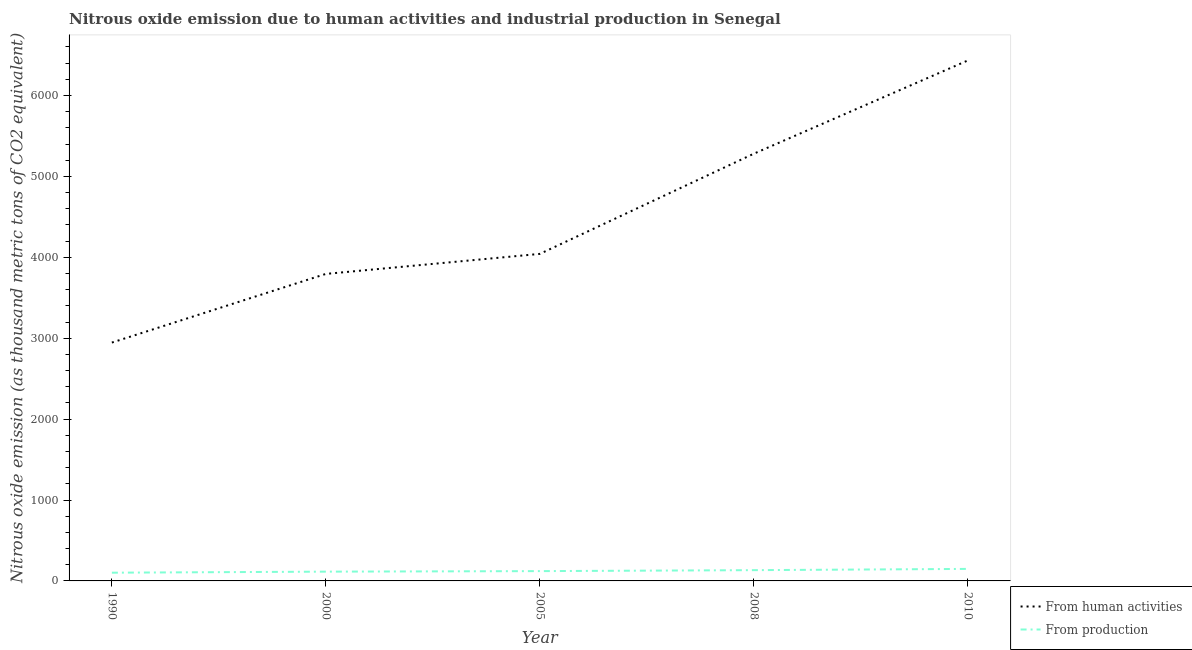How many different coloured lines are there?
Your answer should be compact. 2. What is the amount of emissions generated from industries in 2005?
Offer a terse response. 121.2. Across all years, what is the maximum amount of emissions from human activities?
Make the answer very short. 6433. Across all years, what is the minimum amount of emissions generated from industries?
Provide a succinct answer. 101.7. What is the total amount of emissions from human activities in the graph?
Provide a short and direct response. 2.25e+04. What is the difference between the amount of emissions generated from industries in 2005 and that in 2008?
Your answer should be very brief. -11.9. What is the difference between the amount of emissions generated from industries in 2005 and the amount of emissions from human activities in 2000?
Your answer should be compact. -3673.7. What is the average amount of emissions generated from industries per year?
Your response must be concise. 123.86. In the year 2000, what is the difference between the amount of emissions from human activities and amount of emissions generated from industries?
Keep it short and to the point. 3680.2. What is the ratio of the amount of emissions generated from industries in 1990 to that in 2008?
Provide a succinct answer. 0.76. Is the amount of emissions generated from industries in 1990 less than that in 2005?
Your answer should be compact. Yes. Is the difference between the amount of emissions generated from industries in 1990 and 2010 greater than the difference between the amount of emissions from human activities in 1990 and 2010?
Ensure brevity in your answer.  Yes. What is the difference between the highest and the second highest amount of emissions from human activities?
Make the answer very short. 1152.3. What is the difference between the highest and the lowest amount of emissions from human activities?
Your response must be concise. 3486.7. Is the sum of the amount of emissions generated from industries in 1990 and 2005 greater than the maximum amount of emissions from human activities across all years?
Make the answer very short. No. Does the amount of emissions from human activities monotonically increase over the years?
Keep it short and to the point. Yes. How many lines are there?
Offer a terse response. 2. What is the difference between two consecutive major ticks on the Y-axis?
Offer a very short reply. 1000. Does the graph contain grids?
Offer a very short reply. No. How many legend labels are there?
Your response must be concise. 2. What is the title of the graph?
Give a very brief answer. Nitrous oxide emission due to human activities and industrial production in Senegal. Does "Long-term debt" appear as one of the legend labels in the graph?
Your answer should be compact. No. What is the label or title of the Y-axis?
Offer a terse response. Nitrous oxide emission (as thousand metric tons of CO2 equivalent). What is the Nitrous oxide emission (as thousand metric tons of CO2 equivalent) in From human activities in 1990?
Your answer should be very brief. 2946.3. What is the Nitrous oxide emission (as thousand metric tons of CO2 equivalent) of From production in 1990?
Your answer should be very brief. 101.7. What is the Nitrous oxide emission (as thousand metric tons of CO2 equivalent) of From human activities in 2000?
Give a very brief answer. 3794.9. What is the Nitrous oxide emission (as thousand metric tons of CO2 equivalent) in From production in 2000?
Provide a succinct answer. 114.7. What is the Nitrous oxide emission (as thousand metric tons of CO2 equivalent) of From human activities in 2005?
Provide a short and direct response. 4042.4. What is the Nitrous oxide emission (as thousand metric tons of CO2 equivalent) in From production in 2005?
Your response must be concise. 121.2. What is the Nitrous oxide emission (as thousand metric tons of CO2 equivalent) in From human activities in 2008?
Provide a succinct answer. 5280.7. What is the Nitrous oxide emission (as thousand metric tons of CO2 equivalent) in From production in 2008?
Ensure brevity in your answer.  133.1. What is the Nitrous oxide emission (as thousand metric tons of CO2 equivalent) in From human activities in 2010?
Give a very brief answer. 6433. What is the Nitrous oxide emission (as thousand metric tons of CO2 equivalent) in From production in 2010?
Offer a terse response. 148.6. Across all years, what is the maximum Nitrous oxide emission (as thousand metric tons of CO2 equivalent) of From human activities?
Your response must be concise. 6433. Across all years, what is the maximum Nitrous oxide emission (as thousand metric tons of CO2 equivalent) of From production?
Make the answer very short. 148.6. Across all years, what is the minimum Nitrous oxide emission (as thousand metric tons of CO2 equivalent) of From human activities?
Provide a short and direct response. 2946.3. Across all years, what is the minimum Nitrous oxide emission (as thousand metric tons of CO2 equivalent) of From production?
Provide a short and direct response. 101.7. What is the total Nitrous oxide emission (as thousand metric tons of CO2 equivalent) of From human activities in the graph?
Your answer should be compact. 2.25e+04. What is the total Nitrous oxide emission (as thousand metric tons of CO2 equivalent) in From production in the graph?
Your answer should be very brief. 619.3. What is the difference between the Nitrous oxide emission (as thousand metric tons of CO2 equivalent) of From human activities in 1990 and that in 2000?
Provide a succinct answer. -848.6. What is the difference between the Nitrous oxide emission (as thousand metric tons of CO2 equivalent) in From human activities in 1990 and that in 2005?
Your answer should be very brief. -1096.1. What is the difference between the Nitrous oxide emission (as thousand metric tons of CO2 equivalent) in From production in 1990 and that in 2005?
Your answer should be compact. -19.5. What is the difference between the Nitrous oxide emission (as thousand metric tons of CO2 equivalent) in From human activities in 1990 and that in 2008?
Offer a terse response. -2334.4. What is the difference between the Nitrous oxide emission (as thousand metric tons of CO2 equivalent) of From production in 1990 and that in 2008?
Give a very brief answer. -31.4. What is the difference between the Nitrous oxide emission (as thousand metric tons of CO2 equivalent) of From human activities in 1990 and that in 2010?
Offer a very short reply. -3486.7. What is the difference between the Nitrous oxide emission (as thousand metric tons of CO2 equivalent) of From production in 1990 and that in 2010?
Offer a terse response. -46.9. What is the difference between the Nitrous oxide emission (as thousand metric tons of CO2 equivalent) of From human activities in 2000 and that in 2005?
Provide a succinct answer. -247.5. What is the difference between the Nitrous oxide emission (as thousand metric tons of CO2 equivalent) of From production in 2000 and that in 2005?
Offer a very short reply. -6.5. What is the difference between the Nitrous oxide emission (as thousand metric tons of CO2 equivalent) in From human activities in 2000 and that in 2008?
Offer a terse response. -1485.8. What is the difference between the Nitrous oxide emission (as thousand metric tons of CO2 equivalent) of From production in 2000 and that in 2008?
Your answer should be compact. -18.4. What is the difference between the Nitrous oxide emission (as thousand metric tons of CO2 equivalent) of From human activities in 2000 and that in 2010?
Offer a very short reply. -2638.1. What is the difference between the Nitrous oxide emission (as thousand metric tons of CO2 equivalent) of From production in 2000 and that in 2010?
Give a very brief answer. -33.9. What is the difference between the Nitrous oxide emission (as thousand metric tons of CO2 equivalent) in From human activities in 2005 and that in 2008?
Make the answer very short. -1238.3. What is the difference between the Nitrous oxide emission (as thousand metric tons of CO2 equivalent) in From production in 2005 and that in 2008?
Provide a short and direct response. -11.9. What is the difference between the Nitrous oxide emission (as thousand metric tons of CO2 equivalent) in From human activities in 2005 and that in 2010?
Make the answer very short. -2390.6. What is the difference between the Nitrous oxide emission (as thousand metric tons of CO2 equivalent) of From production in 2005 and that in 2010?
Your answer should be very brief. -27.4. What is the difference between the Nitrous oxide emission (as thousand metric tons of CO2 equivalent) in From human activities in 2008 and that in 2010?
Give a very brief answer. -1152.3. What is the difference between the Nitrous oxide emission (as thousand metric tons of CO2 equivalent) in From production in 2008 and that in 2010?
Offer a very short reply. -15.5. What is the difference between the Nitrous oxide emission (as thousand metric tons of CO2 equivalent) in From human activities in 1990 and the Nitrous oxide emission (as thousand metric tons of CO2 equivalent) in From production in 2000?
Provide a succinct answer. 2831.6. What is the difference between the Nitrous oxide emission (as thousand metric tons of CO2 equivalent) in From human activities in 1990 and the Nitrous oxide emission (as thousand metric tons of CO2 equivalent) in From production in 2005?
Provide a succinct answer. 2825.1. What is the difference between the Nitrous oxide emission (as thousand metric tons of CO2 equivalent) in From human activities in 1990 and the Nitrous oxide emission (as thousand metric tons of CO2 equivalent) in From production in 2008?
Offer a very short reply. 2813.2. What is the difference between the Nitrous oxide emission (as thousand metric tons of CO2 equivalent) in From human activities in 1990 and the Nitrous oxide emission (as thousand metric tons of CO2 equivalent) in From production in 2010?
Your answer should be very brief. 2797.7. What is the difference between the Nitrous oxide emission (as thousand metric tons of CO2 equivalent) in From human activities in 2000 and the Nitrous oxide emission (as thousand metric tons of CO2 equivalent) in From production in 2005?
Your answer should be compact. 3673.7. What is the difference between the Nitrous oxide emission (as thousand metric tons of CO2 equivalent) in From human activities in 2000 and the Nitrous oxide emission (as thousand metric tons of CO2 equivalent) in From production in 2008?
Your answer should be very brief. 3661.8. What is the difference between the Nitrous oxide emission (as thousand metric tons of CO2 equivalent) of From human activities in 2000 and the Nitrous oxide emission (as thousand metric tons of CO2 equivalent) of From production in 2010?
Keep it short and to the point. 3646.3. What is the difference between the Nitrous oxide emission (as thousand metric tons of CO2 equivalent) of From human activities in 2005 and the Nitrous oxide emission (as thousand metric tons of CO2 equivalent) of From production in 2008?
Your response must be concise. 3909.3. What is the difference between the Nitrous oxide emission (as thousand metric tons of CO2 equivalent) of From human activities in 2005 and the Nitrous oxide emission (as thousand metric tons of CO2 equivalent) of From production in 2010?
Provide a succinct answer. 3893.8. What is the difference between the Nitrous oxide emission (as thousand metric tons of CO2 equivalent) in From human activities in 2008 and the Nitrous oxide emission (as thousand metric tons of CO2 equivalent) in From production in 2010?
Your response must be concise. 5132.1. What is the average Nitrous oxide emission (as thousand metric tons of CO2 equivalent) of From human activities per year?
Provide a succinct answer. 4499.46. What is the average Nitrous oxide emission (as thousand metric tons of CO2 equivalent) in From production per year?
Keep it short and to the point. 123.86. In the year 1990, what is the difference between the Nitrous oxide emission (as thousand metric tons of CO2 equivalent) in From human activities and Nitrous oxide emission (as thousand metric tons of CO2 equivalent) in From production?
Give a very brief answer. 2844.6. In the year 2000, what is the difference between the Nitrous oxide emission (as thousand metric tons of CO2 equivalent) in From human activities and Nitrous oxide emission (as thousand metric tons of CO2 equivalent) in From production?
Your answer should be very brief. 3680.2. In the year 2005, what is the difference between the Nitrous oxide emission (as thousand metric tons of CO2 equivalent) in From human activities and Nitrous oxide emission (as thousand metric tons of CO2 equivalent) in From production?
Your answer should be compact. 3921.2. In the year 2008, what is the difference between the Nitrous oxide emission (as thousand metric tons of CO2 equivalent) of From human activities and Nitrous oxide emission (as thousand metric tons of CO2 equivalent) of From production?
Ensure brevity in your answer.  5147.6. In the year 2010, what is the difference between the Nitrous oxide emission (as thousand metric tons of CO2 equivalent) in From human activities and Nitrous oxide emission (as thousand metric tons of CO2 equivalent) in From production?
Your answer should be compact. 6284.4. What is the ratio of the Nitrous oxide emission (as thousand metric tons of CO2 equivalent) of From human activities in 1990 to that in 2000?
Your answer should be compact. 0.78. What is the ratio of the Nitrous oxide emission (as thousand metric tons of CO2 equivalent) of From production in 1990 to that in 2000?
Provide a short and direct response. 0.89. What is the ratio of the Nitrous oxide emission (as thousand metric tons of CO2 equivalent) in From human activities in 1990 to that in 2005?
Provide a short and direct response. 0.73. What is the ratio of the Nitrous oxide emission (as thousand metric tons of CO2 equivalent) of From production in 1990 to that in 2005?
Give a very brief answer. 0.84. What is the ratio of the Nitrous oxide emission (as thousand metric tons of CO2 equivalent) of From human activities in 1990 to that in 2008?
Keep it short and to the point. 0.56. What is the ratio of the Nitrous oxide emission (as thousand metric tons of CO2 equivalent) in From production in 1990 to that in 2008?
Offer a terse response. 0.76. What is the ratio of the Nitrous oxide emission (as thousand metric tons of CO2 equivalent) in From human activities in 1990 to that in 2010?
Your answer should be very brief. 0.46. What is the ratio of the Nitrous oxide emission (as thousand metric tons of CO2 equivalent) in From production in 1990 to that in 2010?
Make the answer very short. 0.68. What is the ratio of the Nitrous oxide emission (as thousand metric tons of CO2 equivalent) in From human activities in 2000 to that in 2005?
Offer a very short reply. 0.94. What is the ratio of the Nitrous oxide emission (as thousand metric tons of CO2 equivalent) in From production in 2000 to that in 2005?
Offer a very short reply. 0.95. What is the ratio of the Nitrous oxide emission (as thousand metric tons of CO2 equivalent) of From human activities in 2000 to that in 2008?
Provide a short and direct response. 0.72. What is the ratio of the Nitrous oxide emission (as thousand metric tons of CO2 equivalent) of From production in 2000 to that in 2008?
Your answer should be compact. 0.86. What is the ratio of the Nitrous oxide emission (as thousand metric tons of CO2 equivalent) in From human activities in 2000 to that in 2010?
Keep it short and to the point. 0.59. What is the ratio of the Nitrous oxide emission (as thousand metric tons of CO2 equivalent) of From production in 2000 to that in 2010?
Provide a succinct answer. 0.77. What is the ratio of the Nitrous oxide emission (as thousand metric tons of CO2 equivalent) of From human activities in 2005 to that in 2008?
Give a very brief answer. 0.77. What is the ratio of the Nitrous oxide emission (as thousand metric tons of CO2 equivalent) in From production in 2005 to that in 2008?
Offer a very short reply. 0.91. What is the ratio of the Nitrous oxide emission (as thousand metric tons of CO2 equivalent) in From human activities in 2005 to that in 2010?
Offer a terse response. 0.63. What is the ratio of the Nitrous oxide emission (as thousand metric tons of CO2 equivalent) of From production in 2005 to that in 2010?
Offer a terse response. 0.82. What is the ratio of the Nitrous oxide emission (as thousand metric tons of CO2 equivalent) of From human activities in 2008 to that in 2010?
Give a very brief answer. 0.82. What is the ratio of the Nitrous oxide emission (as thousand metric tons of CO2 equivalent) of From production in 2008 to that in 2010?
Offer a terse response. 0.9. What is the difference between the highest and the second highest Nitrous oxide emission (as thousand metric tons of CO2 equivalent) of From human activities?
Provide a short and direct response. 1152.3. What is the difference between the highest and the lowest Nitrous oxide emission (as thousand metric tons of CO2 equivalent) of From human activities?
Provide a short and direct response. 3486.7. What is the difference between the highest and the lowest Nitrous oxide emission (as thousand metric tons of CO2 equivalent) of From production?
Offer a terse response. 46.9. 